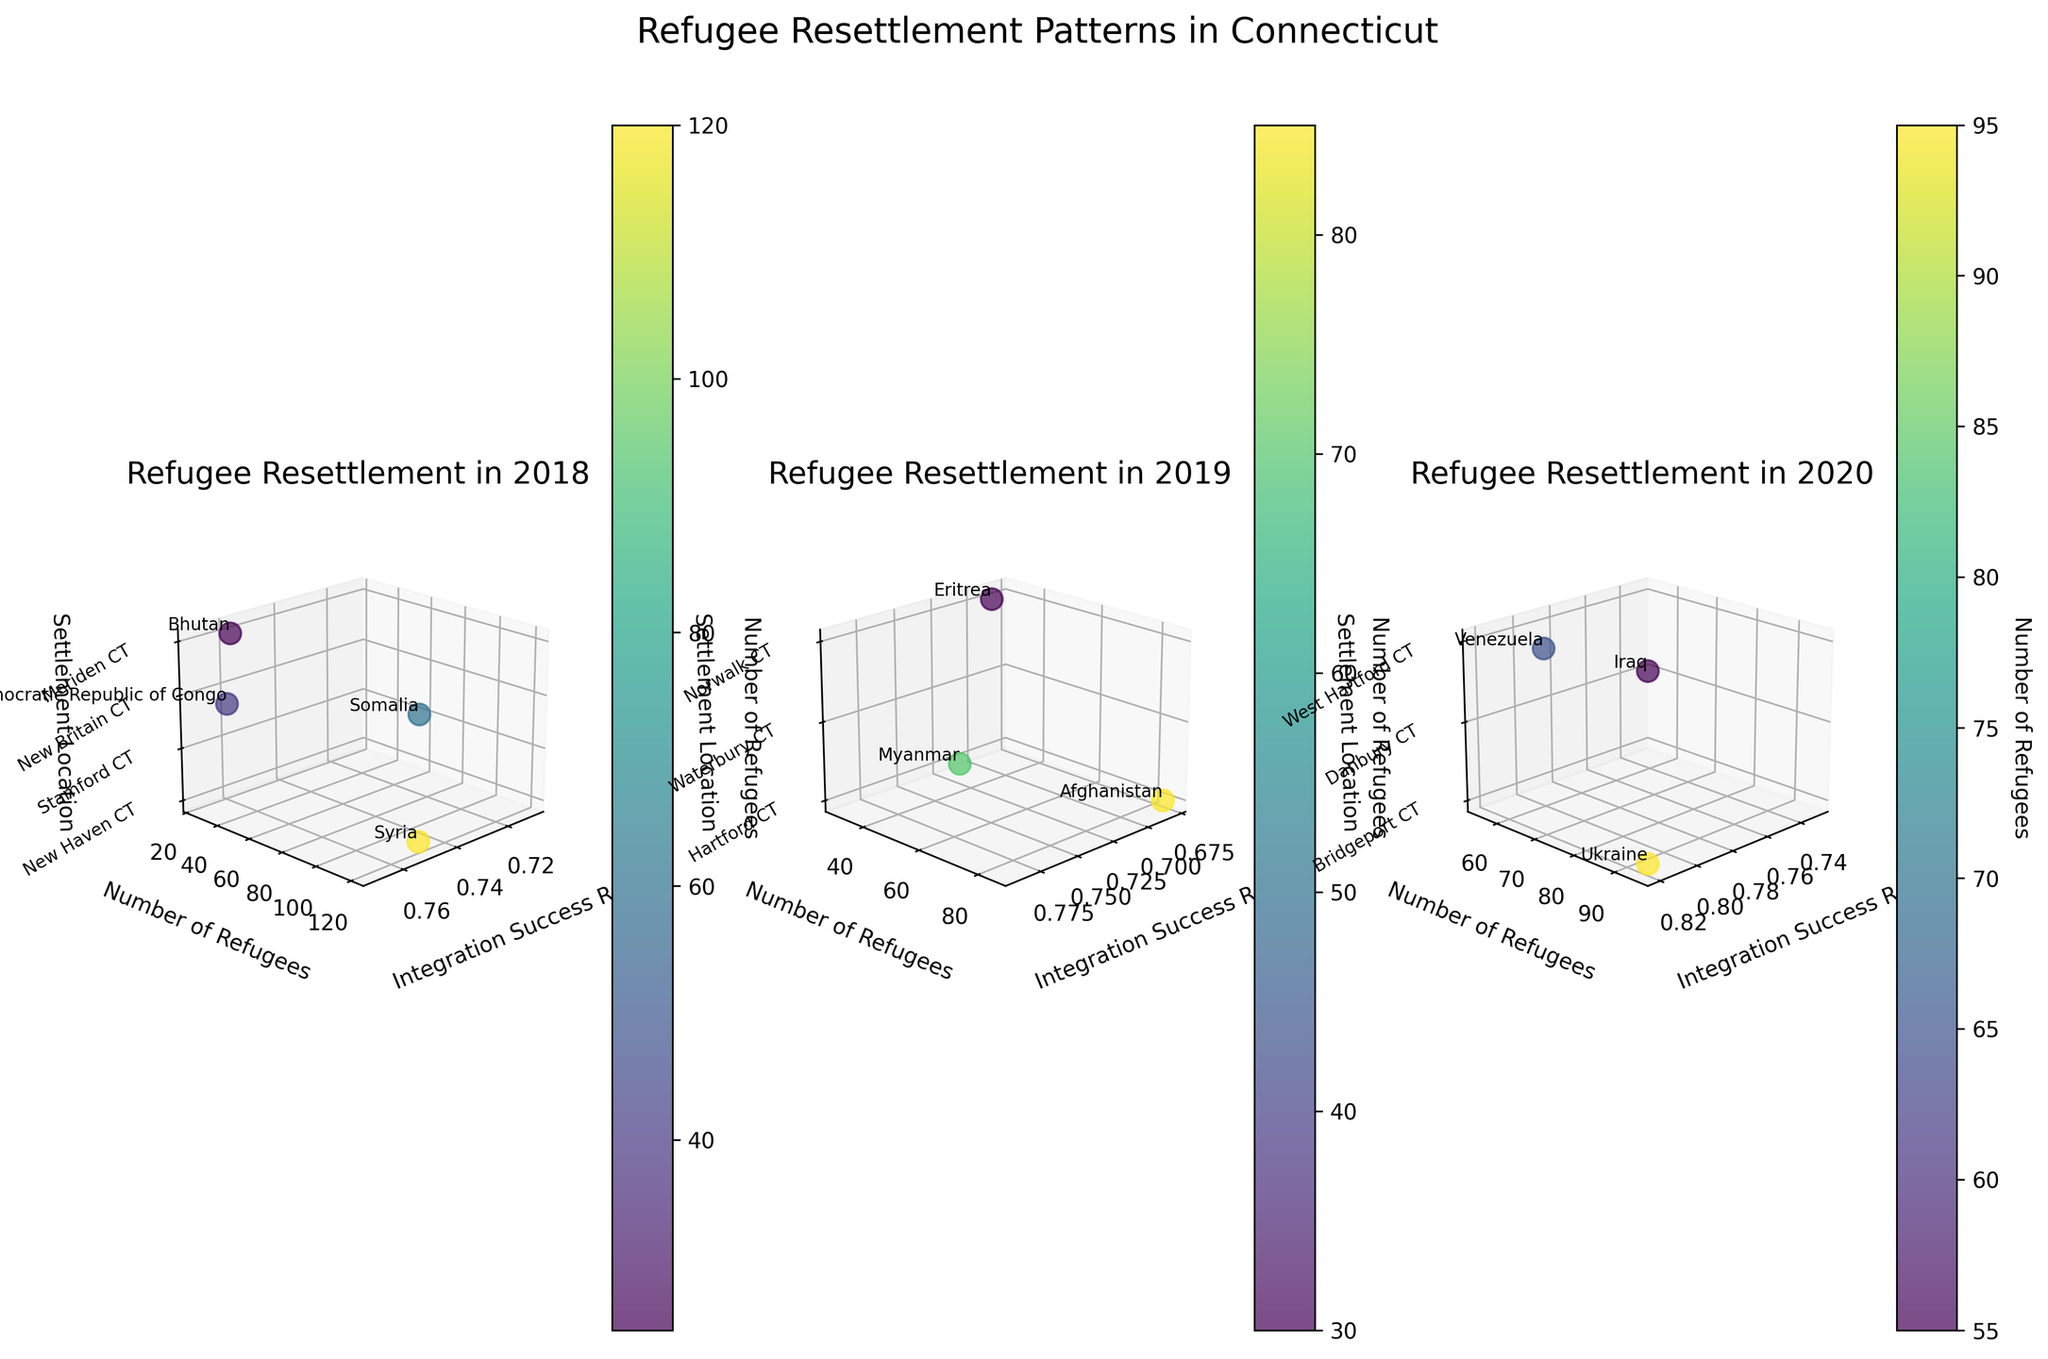How many settlement locations are represented in the 2018 subplot? Count the number of unique settlement locations along the z-axis for the 2018 subplot. The labels along the z-axis denote different cities where refugees resettled in 2018. These are New Haven CT, Stamford CT, New Britain CT, and Meriden CT.
Answer: 4 What's the average integration success rate for refugees in 2019? Identify the integration success rates for all the 2019 data points, which are 0.68 for Hartford CT, 0.79 for Waterbury CT, and 0.69 for Norwalk CT. Adding them gives 2.16, then divide by the number of data points (3). The average is 2.16/3 = 0.72
Answer: 0.72 Which country of origin has the highest number of refugees in 2020? Look for the data point with the highest y-value in the 2020 subplot. The data point with the highest value is New Haven CT with 120 refugees, associated with Syria.
Answer: Syria Comparing New Haven CT in 2018 and Hartford CT in 2019, which has a higher integration success rate? Identify the integration success rate from the 2018 and 2019 plots for New Haven CT (0.75) and Hartford CT (0.68) respectively. Compare these two values.
Answer: New Haven CT How many countries of origin are represented in the 2020 subplot? Count the number of unique texts annotated for countries of origin in the 2020 subplot. These countries include Ukraine, Iraq, and Venezuela.
Answer: 3 What is the difference in the number of refugees between the city with the most refugees and the city with the fewest refugees in 2018? Identify the cities with the most and fewest refugees in the 2018 subplot: New Haven CT (120) and Meriden CT (25). Calculate the difference: 120 - 25 = 95.
Answer: 95 What range of integration success rates is represented in 2018? Find the minimum and maximum integration success rates in the 2018 subplot. The values range from 0.71 for Stamford CT to 0.76 for Meriden CT.
Answer: 0.71 to 0.76 Which year shows the highest overall integration success rate among the top refugee settlements? Compare the integration success rates of top refugee settlements across all three years. The highest value noted is 0.82 for Ukraine (Bridgeport CT) in 2020.
Answer: 2020 